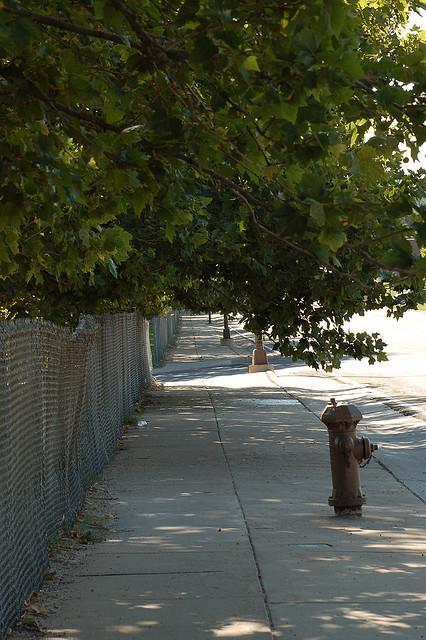Are there leaves on the trees?
Answer briefly. Yes. Are there flowers in the photo?
Answer briefly. No. Are there leaves on the ground?
Give a very brief answer. Yes. How many fire hydrants are pictured?
Short answer required. 1. 